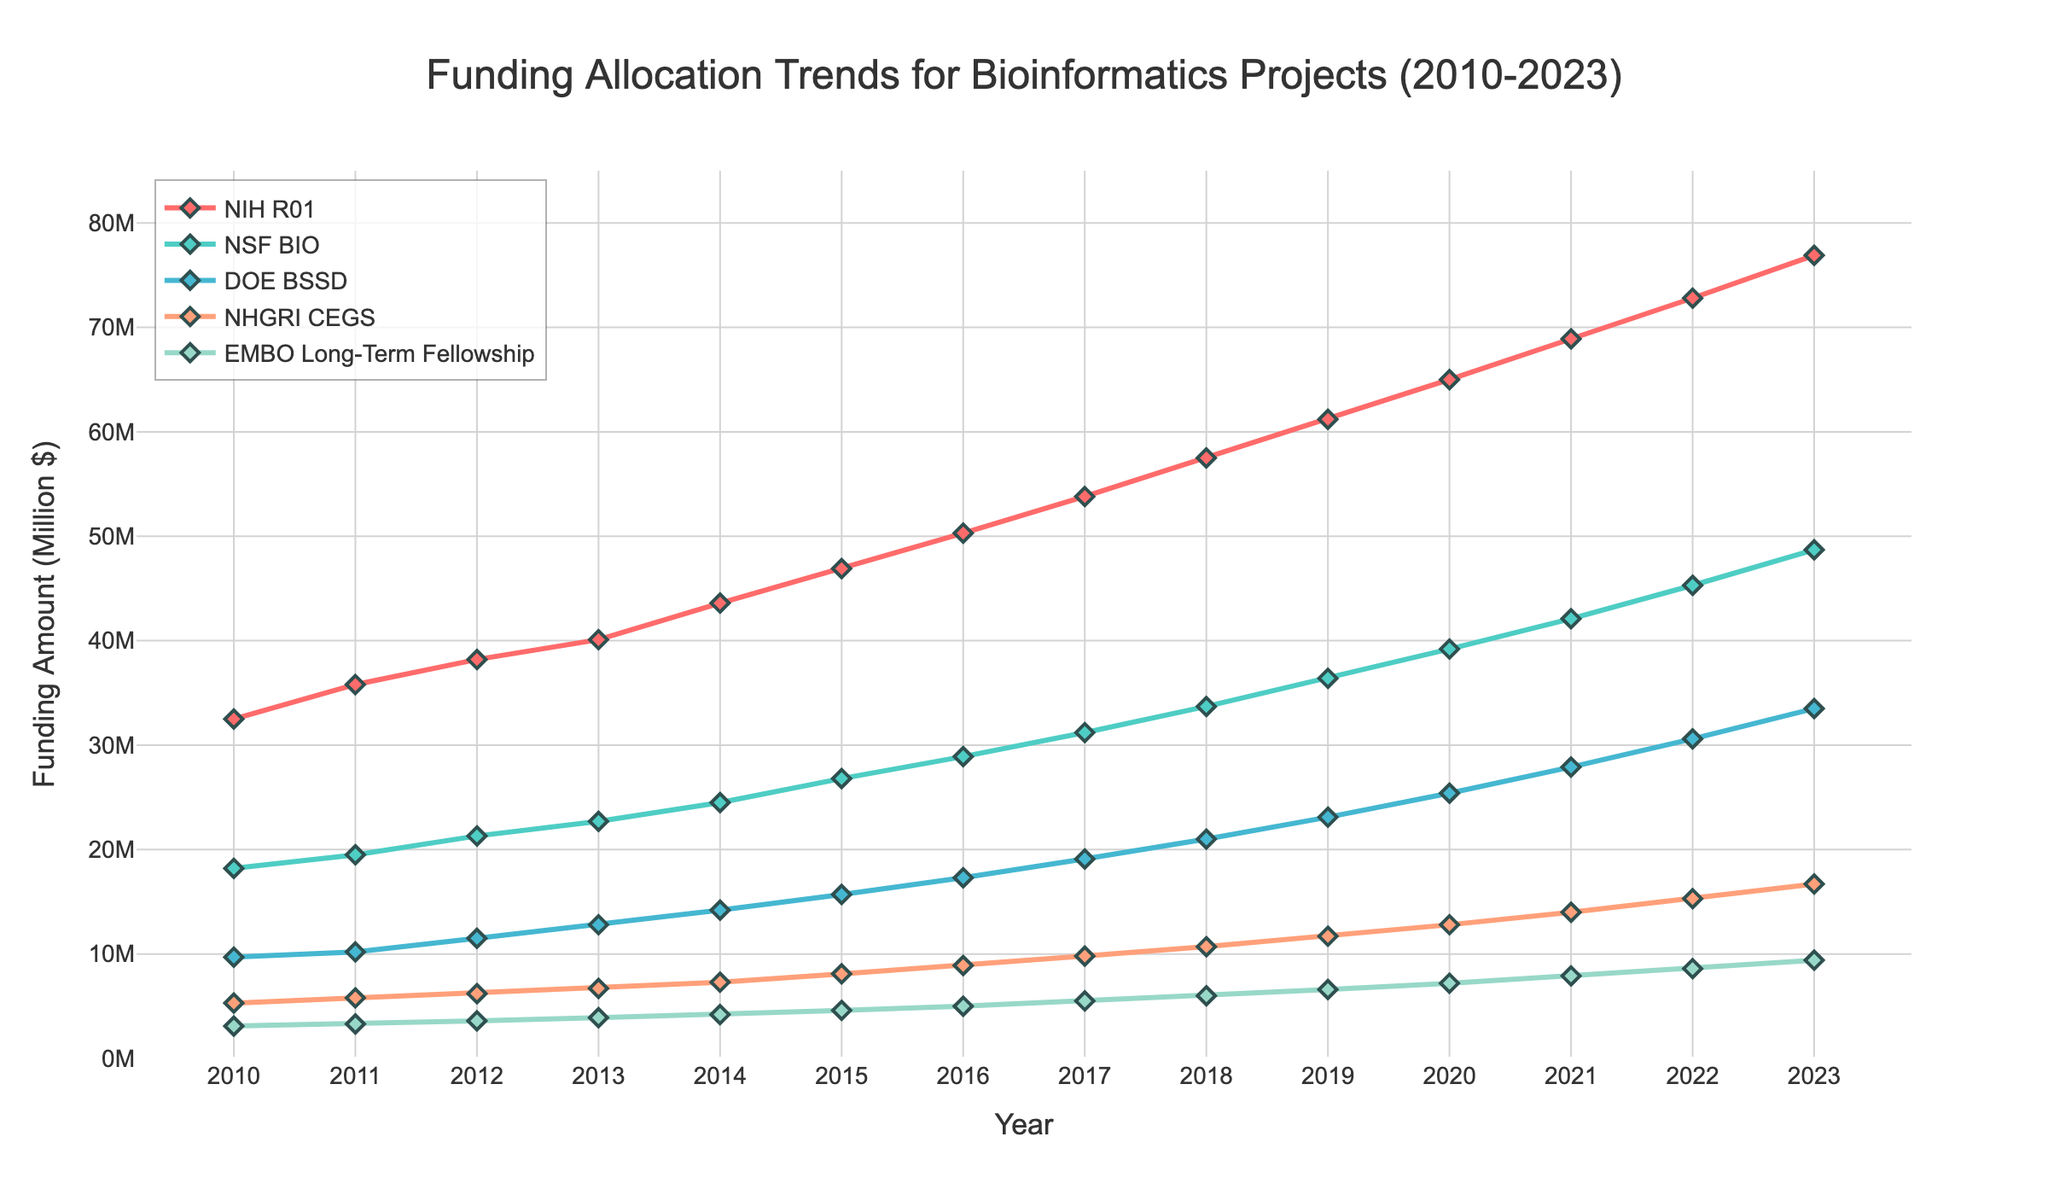Which grant program had the highest funding amount in 2023? The figure shows that the NIH R01 program had the highest funding amount in 2023. This can be observed as the topmost line in the chart at the rightmost point.
Answer: NIH R01 What is the overall trend of funding allocation for the NSF BIO program between 2010 and 2023? The funding for NSF BIO shows a consistent upward trend from 18.2 million in 2010 to 48.7 million in 2023. Observing the line corresponding to NSF BIO, we can see it steadily rises over the years.
Answer: Consistent upward trend Compare the funding allocated to NIH R01 and DOE BSSD in 2015. Which one received more funding and by how much? In 2015, NIH R01 received 46.9 million while DOE BSSD received 15.7 million. By subtracting these two values, we find that NIH R01 received 31.2 million more funding.
Answer: NIH R01 by 31.2 million What is the difference in funding between NHGRI CEGS and EMBO Long-Term Fellowship in 2023? NHGRI CEGS received 16.7 million and EMBO Long-Term Fellowship received 9.4 million. The difference is 16.7 - 9.4 = 7.3 million.
Answer: 7.3 million Determine the annual average funding increase for the NIH R01 program from 2010 to 2023. The funding for NIH R01 in 2010 was 32.5 million, and in 2023, it was 76.9 million. The difference is 76.9 - 32.5 = 44.4 million over 13 years. The average annual increase is 44.4 / 13 ≈ 3.42 million.
Answer: Approximately 3.42 million Which program experienced the highest percent increase in funding from 2010 to 2023? Calculate the percent increase for each program. NIH R01: ((76.9 - 32.5) / 32.5) * 100 ≈ 136.31%, NSF BIO: ((48.7 - 18.2) / 18.2) * 100 ≈ 167.58%, DOE BSSD: ((33.5 - 9.7) / 9.7) * 100 ≈ 245.36%, NHGRI CEGS: ((16.7 - 5.3) / 5.3) * 100 ≈ 215.09%, EMBO Long-Term Fellowship: ((9.4 - 3.1) / 3.1) * 100 ≈ 203.23%. DOE BSSD had the highest percent increase at approximately 245.36%.
Answer: DOE BSSD How many years did it take for EMBO Long-Term Fellowship funding to double from its 2010 amount? In 2010, EMBO Long-Term Fellowship was 3.1 million. Doubling 3.1 million is 6.2 million, which was first exceeded in 2018 with a funding of 6.0 million. The next year, 2019, it was 6.6 million. So, it took from 2010 to 2019, which is 9 years.
Answer: 9 years In which year did the NHGRI CEGS funding first exceed 10 million? The NHGRI CEGS funding exceeded 10 million in the year 2018. This can be observed by finding where its line first crosses the 10 million mark on the y-axis.
Answer: 2018 Which program had the lowest funding in 2020, and what was the amount? The EMBO Long-Term Fellowship had the lowest funding in 2020, with an amount of 7.2 million. This is determined by identifying the lowest point on the lines corresponding to 2020.
Answer: EMBO Long-Term Fellowship with 7.2 million What is the sum of funding amounts for all programs in the year 2023? Summing the funding amounts for 2023: NIH R01 (76.9) + NSF BIO (48.7) + DOE BSSD (33.5) + NHGRI CEGS (16.7) + EMBO Long-Term Fellowship (9.4) = 185.2 million.
Answer: 185.2 million 